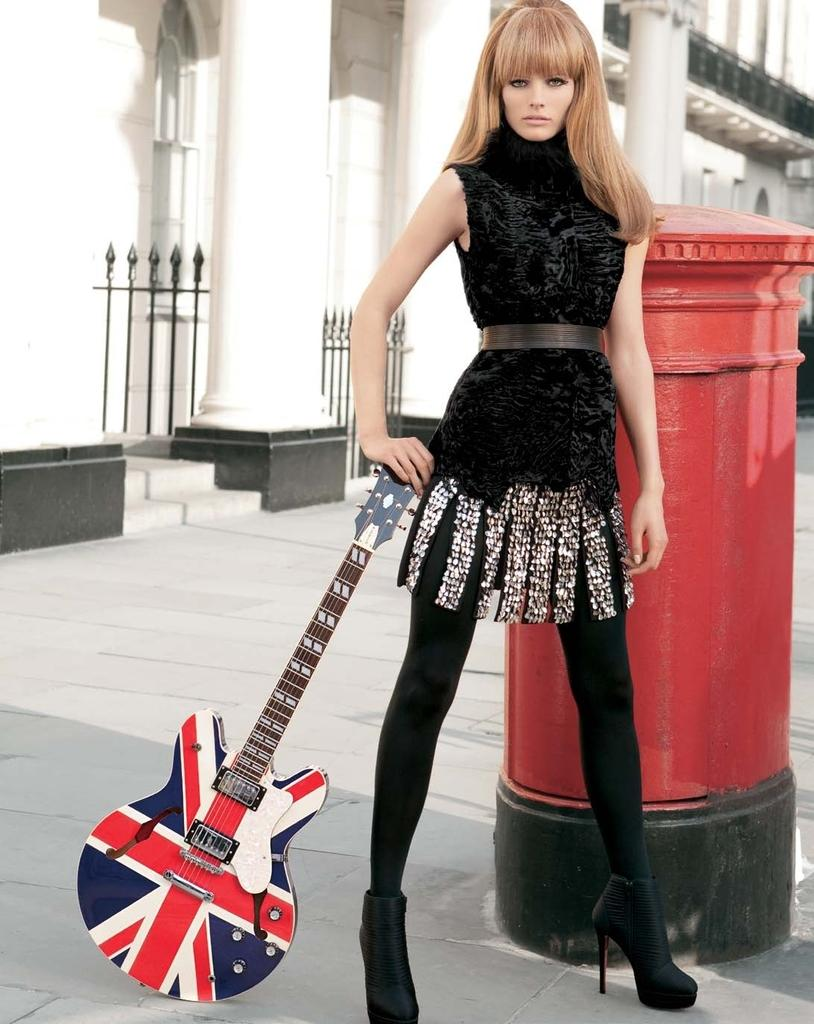Who is present in the image? There is a woman in the image. What is the woman doing in the image? The woman is standing and holding a guitar. What can be seen in the background of the image? There is a building and a post box in the background of the image. Is there a volcano erupting in the background of the image? No, there is no volcano present in the image. Can you see a clam shell near the woman's feet in the image? No, there is no clam shell visible in the image. 